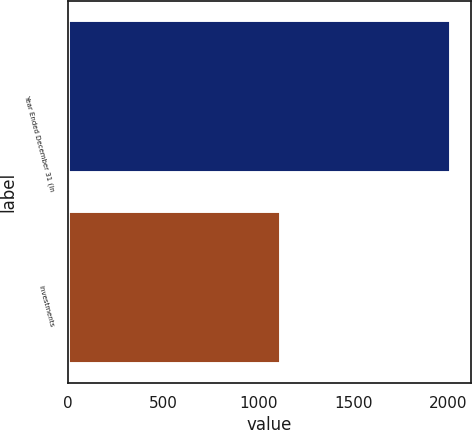<chart> <loc_0><loc_0><loc_500><loc_500><bar_chart><fcel>Year Ended December 31 (In<fcel>investments<nl><fcel>2015<fcel>1119<nl></chart> 